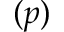<formula> <loc_0><loc_0><loc_500><loc_500>( p )</formula> 